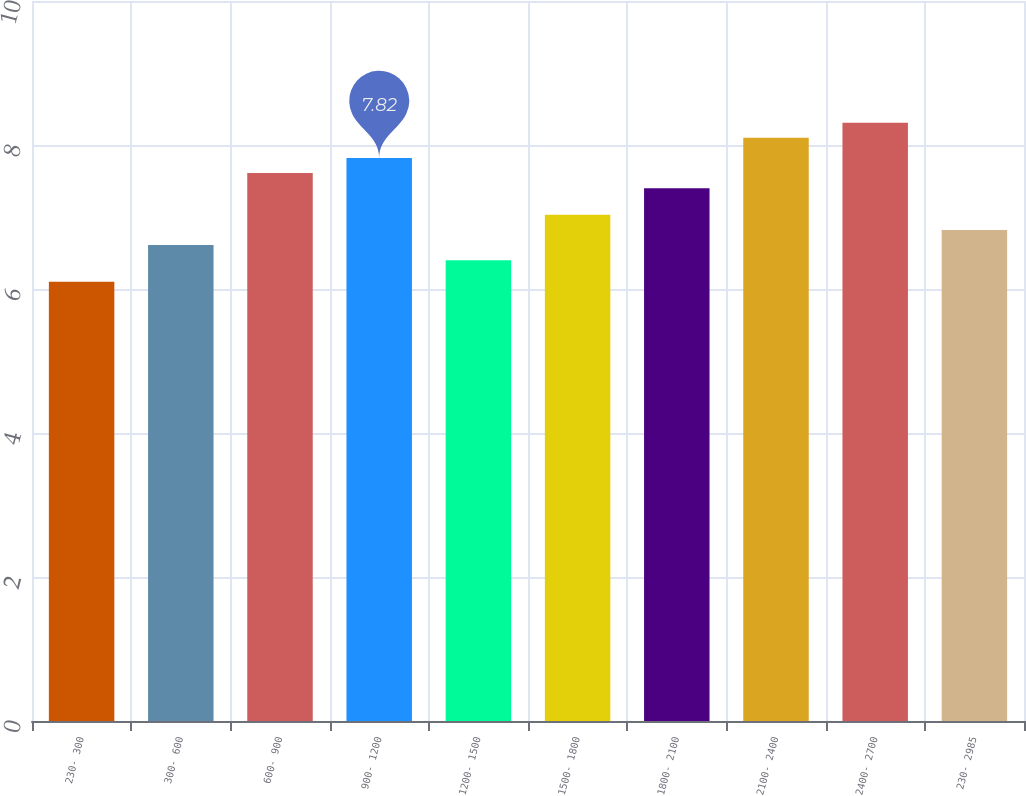<chart> <loc_0><loc_0><loc_500><loc_500><bar_chart><fcel>230- 300<fcel>300- 600<fcel>600- 900<fcel>900- 1200<fcel>1200- 1500<fcel>1500- 1800<fcel>1800- 2100<fcel>2100- 2400<fcel>2400- 2700<fcel>230- 2985<nl><fcel>6.1<fcel>6.61<fcel>7.61<fcel>7.82<fcel>6.4<fcel>7.03<fcel>7.4<fcel>8.1<fcel>8.31<fcel>6.82<nl></chart> 